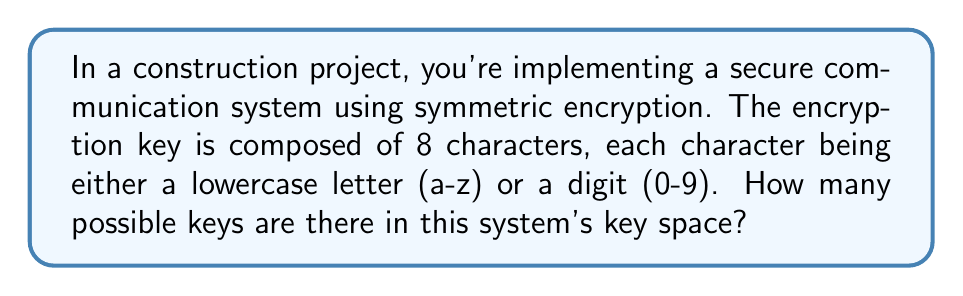Help me with this question. Let's approach this step-by-step:

1) First, we need to determine how many possible choices we have for each character in the key:
   - 26 lowercase letters (a-z)
   - 10 digits (0-9)
   Total choices per character: $26 + 10 = 36$

2) Now, we need to consider that we have 8 characters in the key, and each character can be any of these 36 possibilities.

3) In cryptography, when we have a series of independent choices, we multiply the number of possibilities for each choice. This is known as the multiplication principle.

4) Therefore, the total number of possible keys is:

   $$ 36^8 $$

5) To calculate this:
   $$ 36^8 = 2,821,109,907,456 $$

This large number demonstrates why even relatively short keys can provide strong security in symmetric encryption systems, making them suitable for protecting sensitive construction project information.
Answer: $2,821,109,907,456$ 